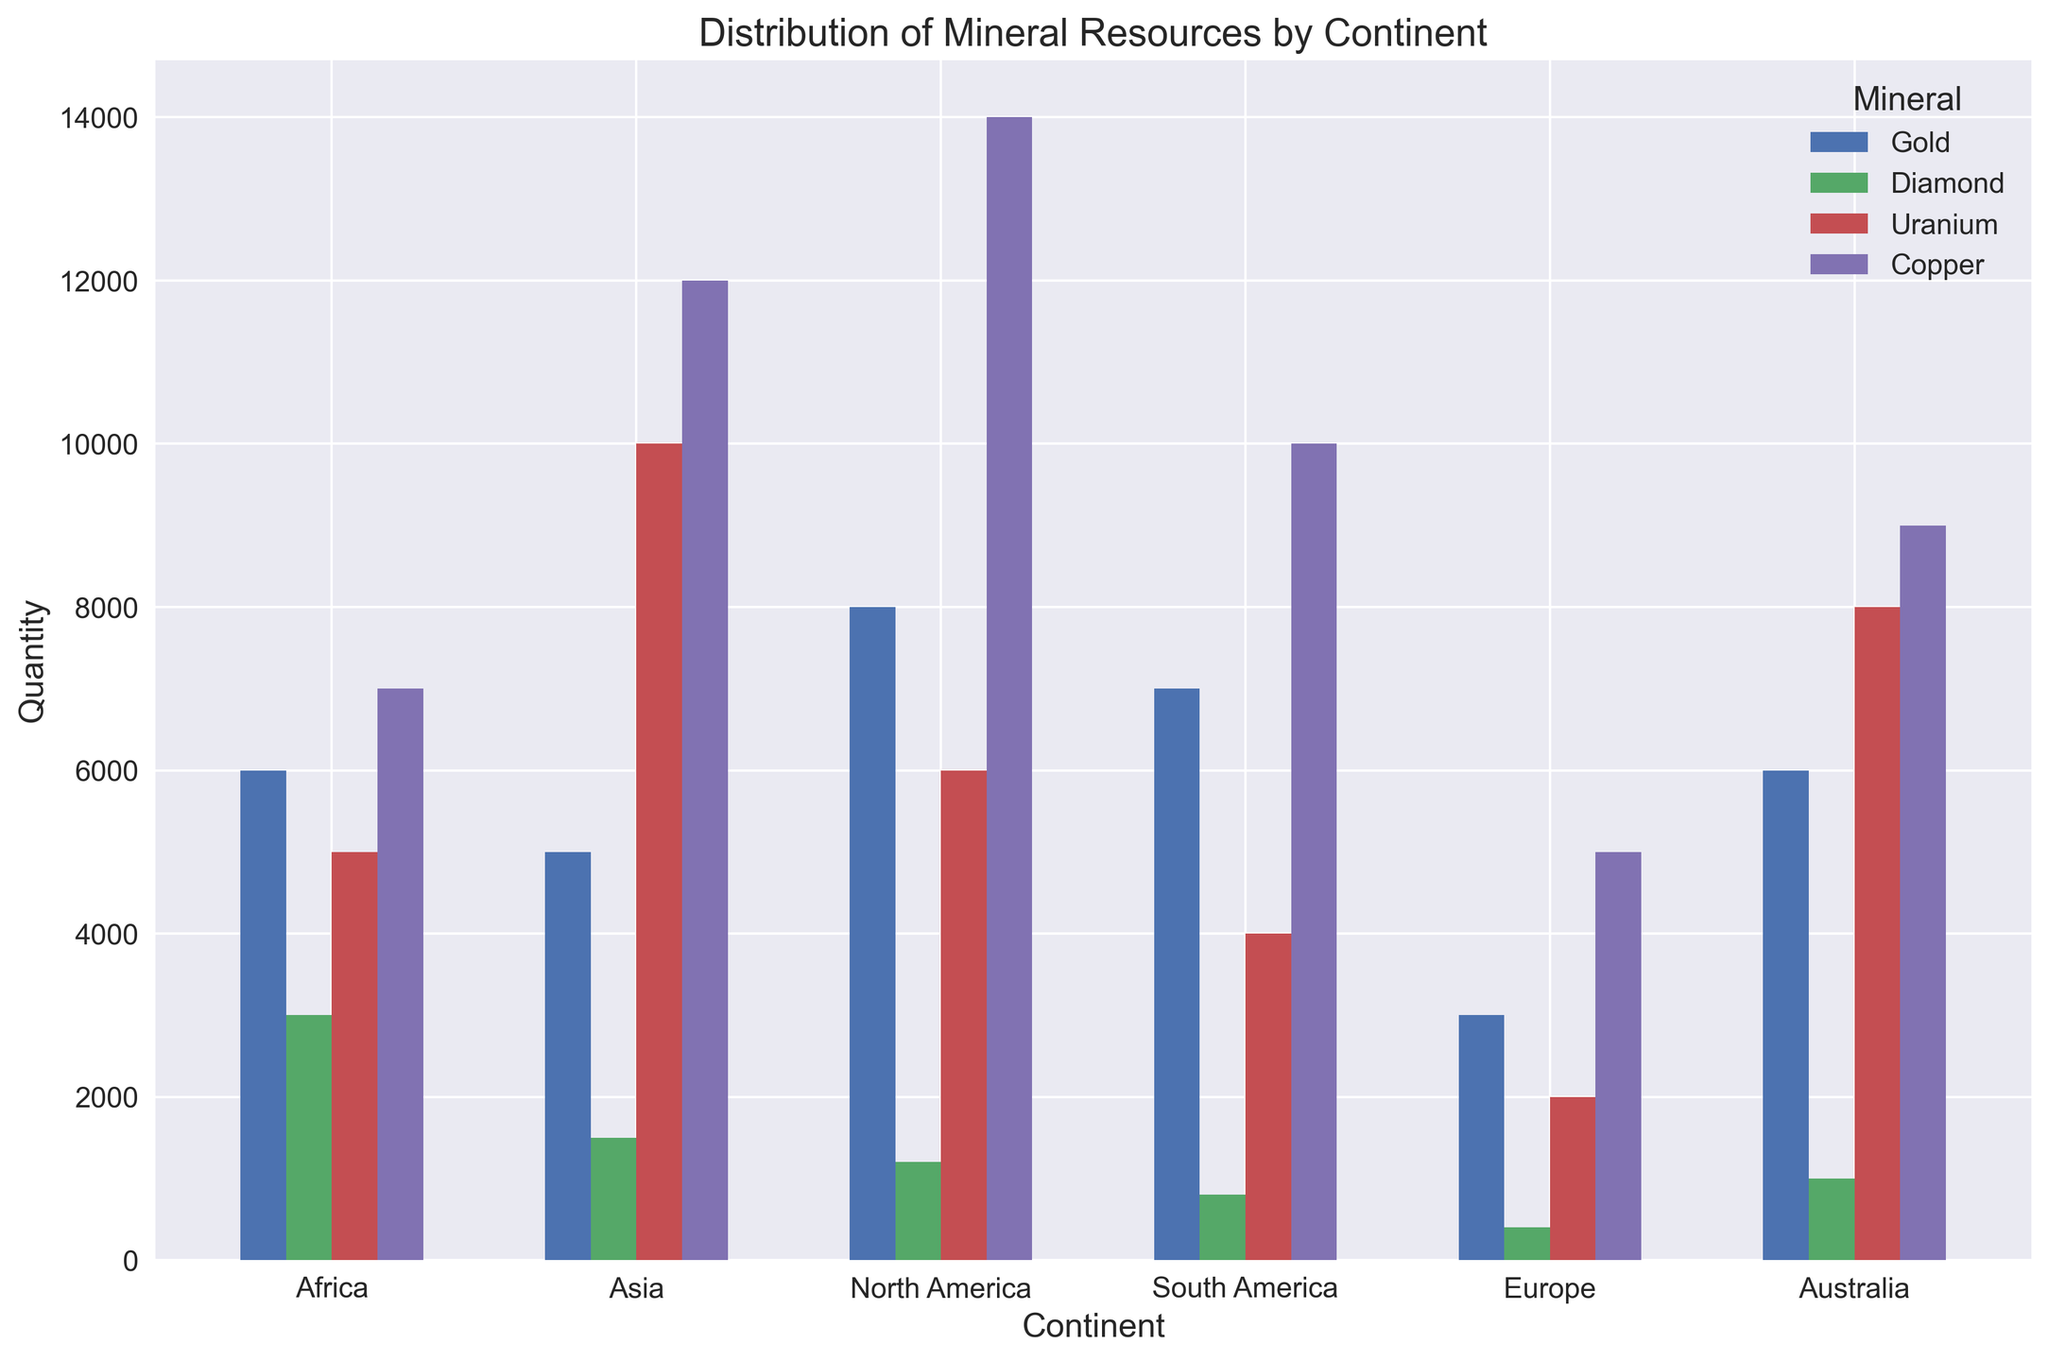Which continent has the highest quantity of Copper? Observe the height of the bars labeled for Copper across different continents. North America's bar is the tallest for Copper.
Answer: North America Which mineral has the lowest quantity in Europe? Look at the heights of each mineral's bar in Europe. The bar for Diamond is the shortest.
Answer: Diamond Which continent has the smallest total quantity of minerals? Sum the heights of all bars for each continent. Europe has the smallest total height.
Answer: Europe Which mineral is most abundant in Asia? Compare the heights of all mineral bars in Asia. The Uranium bar has the greatest height.
Answer: Uranium What is the difference in Gold quantity between Africa and South America? Look at the heights of the Gold bars in Africa and South America. Africa has 6,000 and South America has 7,000, the difference is 7,000 - 6,000.
Answer: 1,000 Which continent has the highest total quantity of minerals? Sum the heights of all bars for each continent. North America has the highest total.
Answer: North America What is the combined quantity of Uranium in Africa and Europe? Add the heights of the Uranium bars in both Africa and Europe. Africa has 5,000 and Europe has 2,000, so the combined total is 5,000 + 2,000.
Answer: 7,000 How much more Copper does North America have compared to Australia? Compare the heights of the Copper bars in North America and Australia. North America has 14,000 and Australia has 9,000, so the difference is 14,000 - 9,000.
Answer: 5,000 Which mineral shows the least variation in quantity across the continents? Assess the consistency of bar heights across all continents for each mineral. Diamond bars show the least variation as they are consistently shorter.
Answer: Diamond 